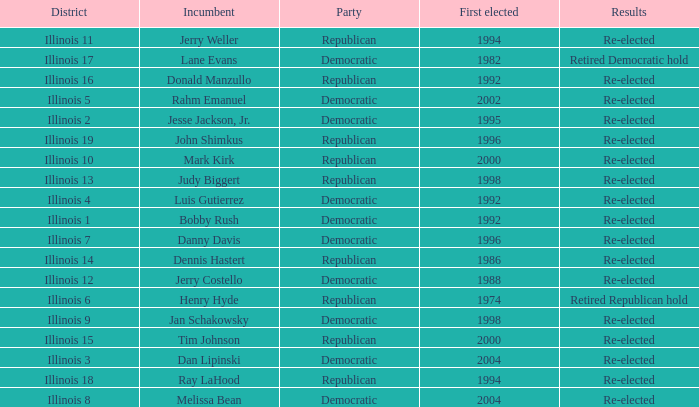What is Illinois 13 District's Party? Republican. 